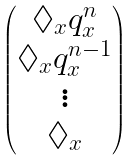<formula> <loc_0><loc_0><loc_500><loc_500>\begin{pmatrix} \Diamond _ { x } q _ { x } ^ { n } \\ \Diamond _ { x } q _ { x } ^ { n - 1 } \\ \vdots \\ \Diamond _ { x } \end{pmatrix}</formula> 